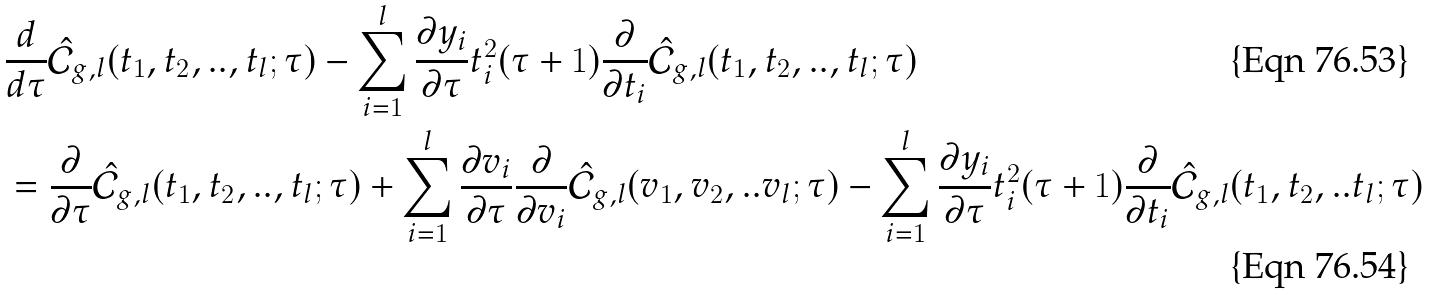Convert formula to latex. <formula><loc_0><loc_0><loc_500><loc_500>& \frac { d } { d \tau } \hat { \mathcal { C } } _ { g , l } ( t _ { 1 } , t _ { 2 } , . . , t _ { l } ; \tau ) - \sum _ { i = 1 } ^ { l } \frac { \partial y _ { i } } { \partial \tau } t _ { i } ^ { 2 } ( \tau + 1 ) \frac { \partial } { \partial t _ { i } } \hat { \mathcal { C } } _ { g , l } ( t _ { 1 } , t _ { 2 } , . . , t _ { l } ; \tau ) \\ & = \frac { \partial } { \partial \tau } \hat { \mathcal { C } } _ { g , l } ( t _ { 1 } , t _ { 2 } , . . , t _ { l } ; \tau ) + \sum _ { i = 1 } ^ { l } \frac { \partial v _ { i } } { \partial \tau } \frac { \partial } { \partial v _ { i } } \hat { \mathcal { C } } _ { g , l } ( v _ { 1 } , v _ { 2 } , . . v _ { l } ; \tau ) - \sum _ { i = 1 } ^ { l } \frac { \partial y _ { i } } { \partial \tau } t _ { i } ^ { 2 } ( \tau + 1 ) \frac { \partial } { \partial t _ { i } } \hat { \mathcal { C } } _ { g , l } ( t _ { 1 } , t _ { 2 } , . . t _ { l } ; \tau )</formula> 